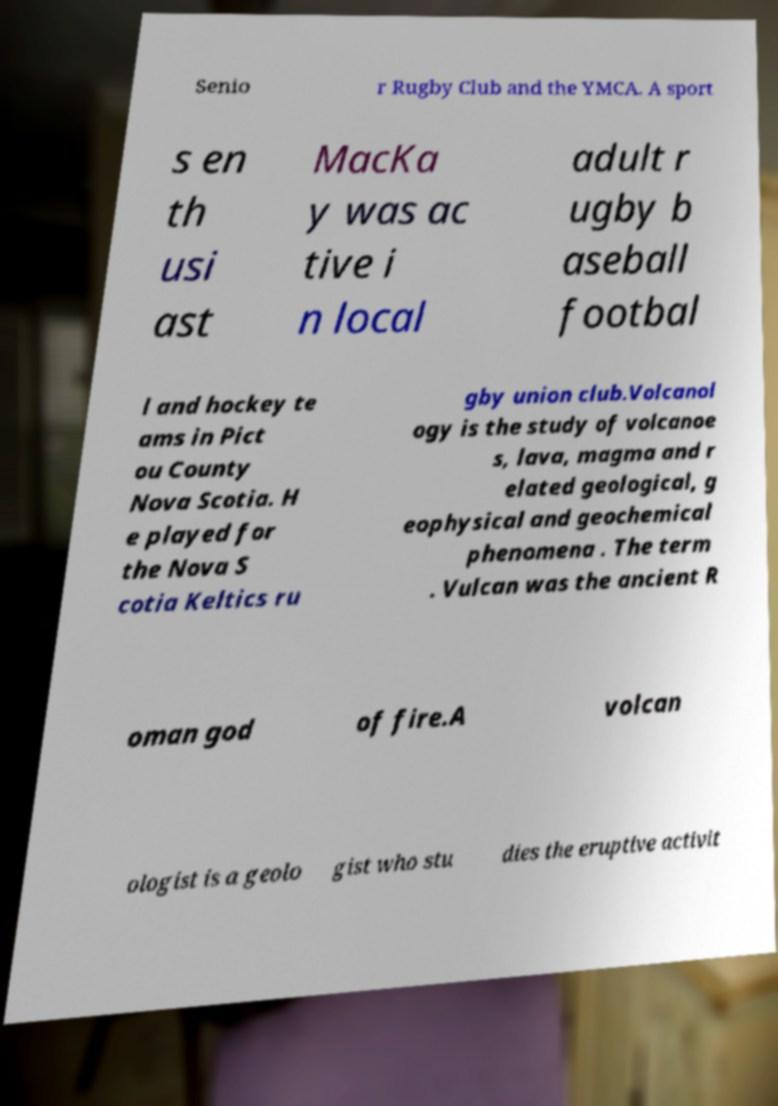Could you assist in decoding the text presented in this image and type it out clearly? Senio r Rugby Club and the YMCA. A sport s en th usi ast MacKa y was ac tive i n local adult r ugby b aseball footbal l and hockey te ams in Pict ou County Nova Scotia. H e played for the Nova S cotia Keltics ru gby union club.Volcanol ogy is the study of volcanoe s, lava, magma and r elated geological, g eophysical and geochemical phenomena . The term . Vulcan was the ancient R oman god of fire.A volcan ologist is a geolo gist who stu dies the eruptive activit 